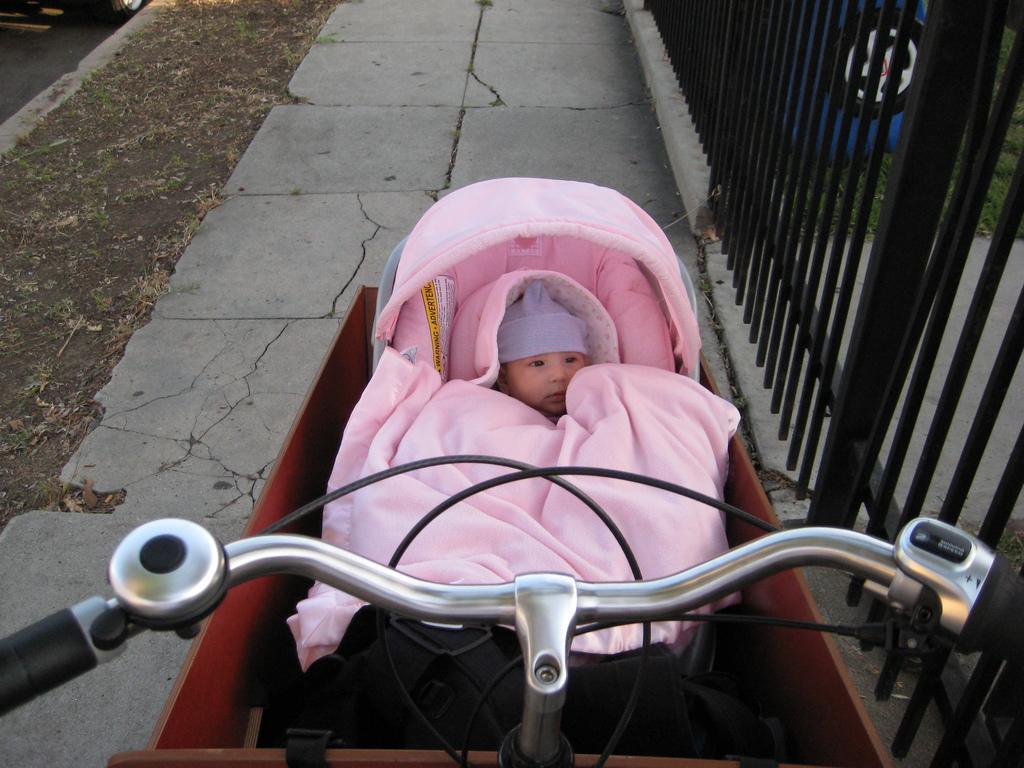What can be seen in the image that is used for steering? There is a cycle handle in the image. What type of vehicle is present in the image? There is a trolley in the image. What color is the cloth on the trolley? The trolley has a pink cloth on it. Who or what is in the trolley? There is a baby in the trolley. What is visible in the background of the image? There is a path visible in the image. What objects with a black color can be seen in the image? There are black color rods in the image. What type of pleasure does the baby experience while riding in the trolley? The image does not provide information about the baby's emotions or experiences, so it cannot be determined from the image. 